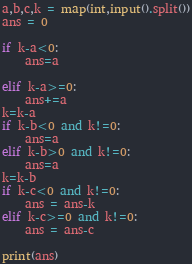<code> <loc_0><loc_0><loc_500><loc_500><_Python_>a,b,c,k = map(int,input().split())
ans = 0

if k-a<0:
    ans=a

elif k-a>=0:
    ans+=a
k=k-a
if k-b<0 and k!=0:
    ans=a
elif k-b>0 and k!=0:
    ans=a
k=k-b
if k-c<0 and k!=0:
    ans = ans-k
elif k-c>=0 and k!=0:
    ans = ans-c

print(ans)
</code> 